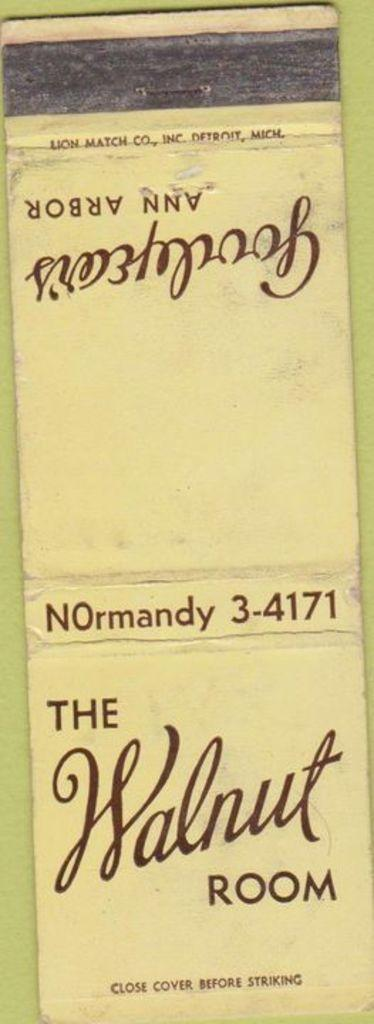Provide a one-sentence caption for the provided image. a faded yellow matchbook from the walnut room. 